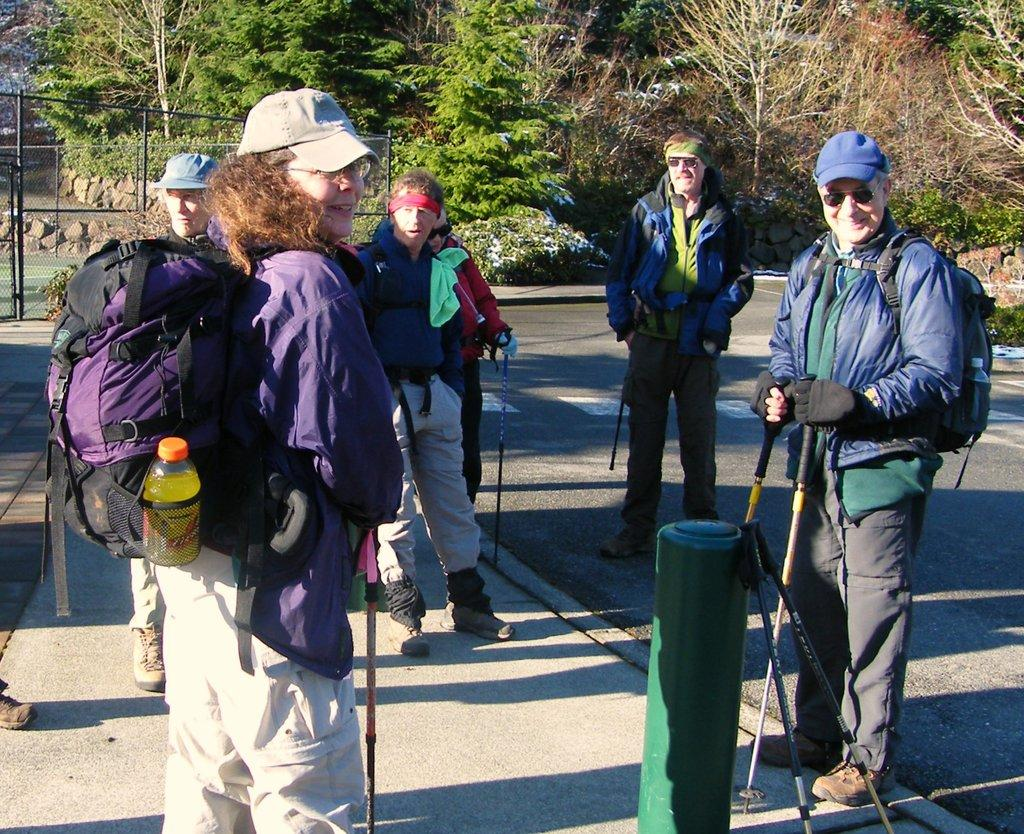What are the people in the image doing? The group of people is standing on the road. What object can be seen near the people? There is a traveling bag in the image. What can be seen in the distance in the image? Trees are visible in the background of the image. What type of string is being used to hold the crack in the image? There is no string or crack present in the image. 